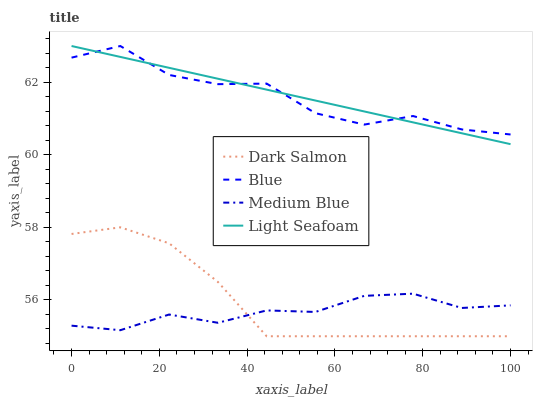Does Medium Blue have the minimum area under the curve?
Answer yes or no. Yes. Does Light Seafoam have the maximum area under the curve?
Answer yes or no. Yes. Does Light Seafoam have the minimum area under the curve?
Answer yes or no. No. Does Medium Blue have the maximum area under the curve?
Answer yes or no. No. Is Light Seafoam the smoothest?
Answer yes or no. Yes. Is Blue the roughest?
Answer yes or no. Yes. Is Medium Blue the smoothest?
Answer yes or no. No. Is Medium Blue the roughest?
Answer yes or no. No. Does Dark Salmon have the lowest value?
Answer yes or no. Yes. Does Light Seafoam have the lowest value?
Answer yes or no. No. Does Light Seafoam have the highest value?
Answer yes or no. Yes. Does Medium Blue have the highest value?
Answer yes or no. No. Is Dark Salmon less than Light Seafoam?
Answer yes or no. Yes. Is Blue greater than Dark Salmon?
Answer yes or no. Yes. Does Blue intersect Light Seafoam?
Answer yes or no. Yes. Is Blue less than Light Seafoam?
Answer yes or no. No. Is Blue greater than Light Seafoam?
Answer yes or no. No. Does Dark Salmon intersect Light Seafoam?
Answer yes or no. No. 